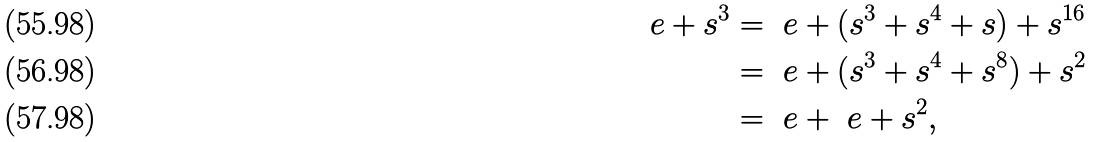Convert formula to latex. <formula><loc_0><loc_0><loc_500><loc_500>\ e + s ^ { 3 } & = \ e + ( s ^ { 3 } + s ^ { 4 } + s ) + s ^ { 1 6 } \\ & = \ e + ( s ^ { 3 } + s ^ { 4 } + s ^ { 8 } ) + s ^ { 2 } \\ & = \ e + \ e + s ^ { 2 } ,</formula> 